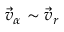Convert formula to latex. <formula><loc_0><loc_0><loc_500><loc_500>\vec { v } _ { \alpha } \sim \vec { v } _ { r }</formula> 